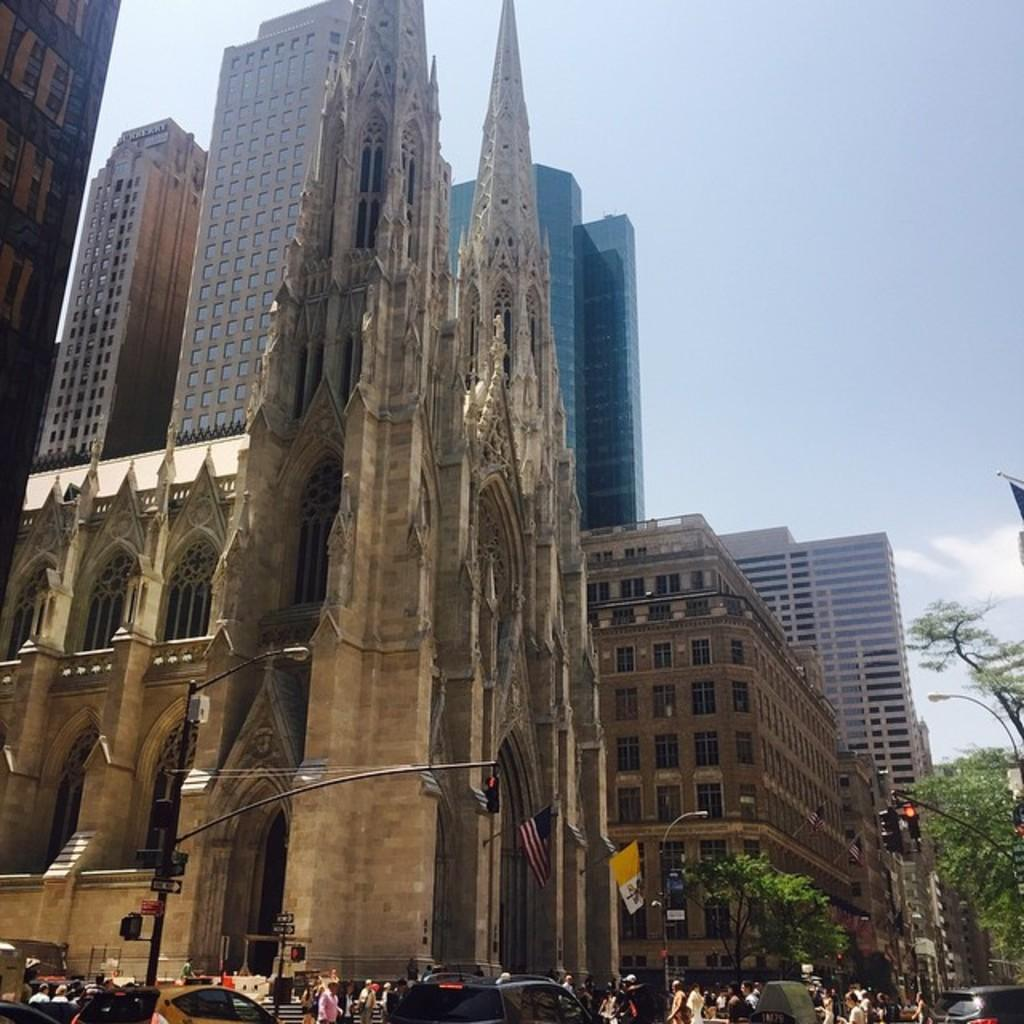What can be seen in the image? There are people, vehicles, traffic signals, trees, buildings, flags, and the sky visible in the image. Can you describe the vehicles in the image? The vehicles in the image are not specified, but they are present. Where are the trees located in the image? The trees are on the right side of the image. What is visible in the background of the image? Buildings are visible in the background of the image. How many flags are present in the image? There are flags in the image, but the exact number is not specified. What is visible at the top of the image? The sky is visible at the top of the image. What type of weather can be seen on the tongue of the person in the image? There is no person's tongue visible in the image, and therefore no weather can be observed on it. Is there a dock present in the image? There is no dock mentioned or visible in the image. 